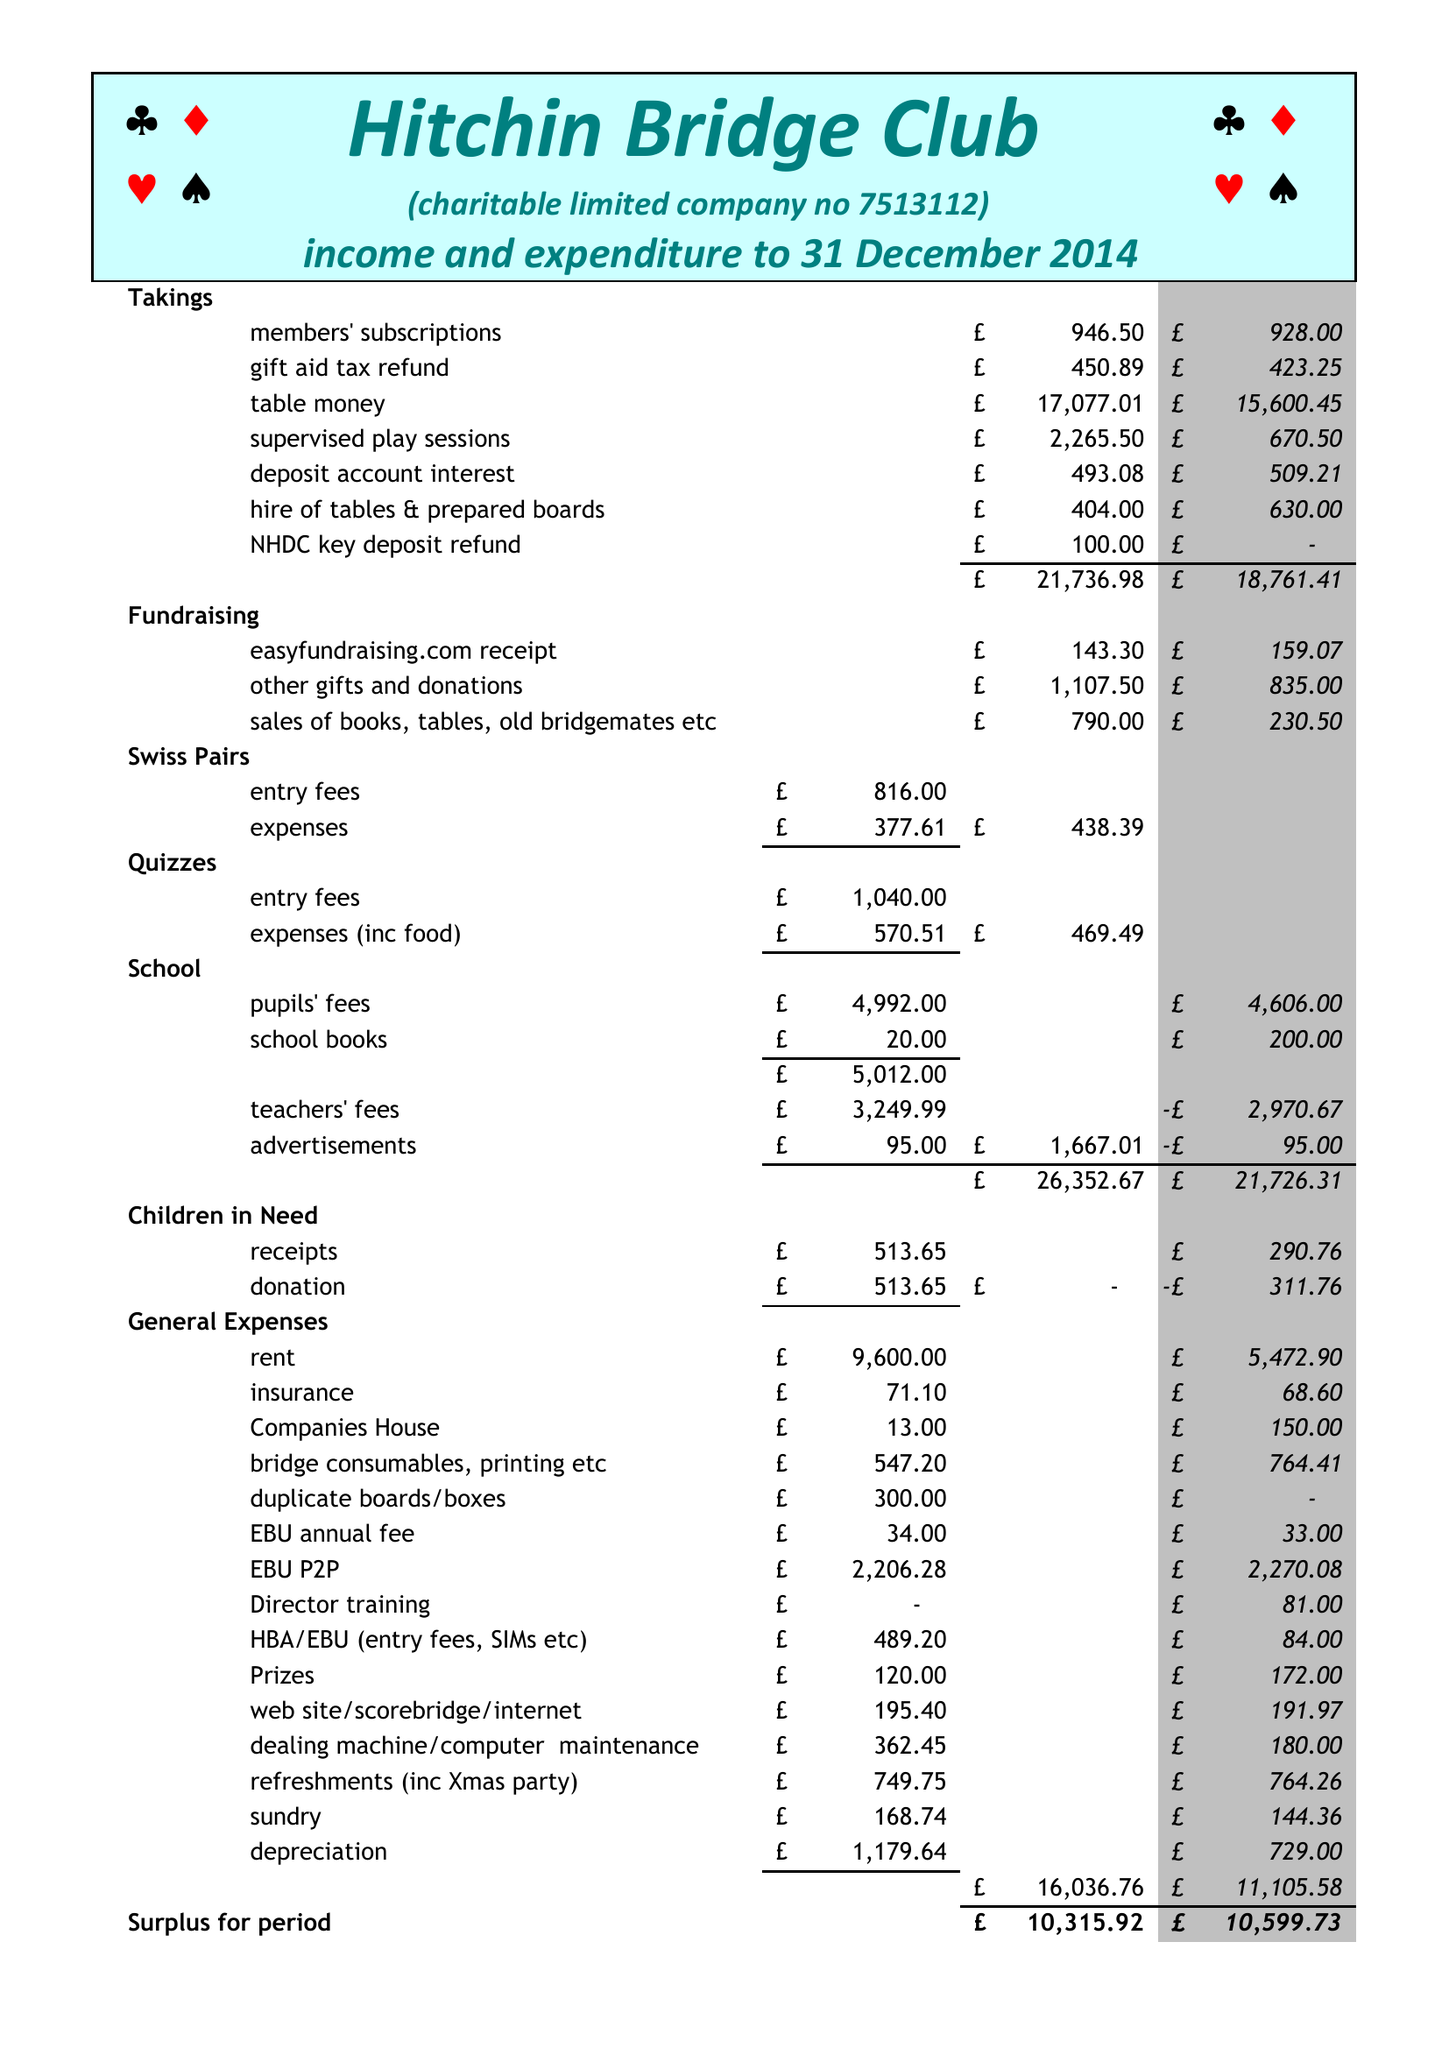What is the value for the address__post_town?
Answer the question using a single word or phrase. HITCHIN 